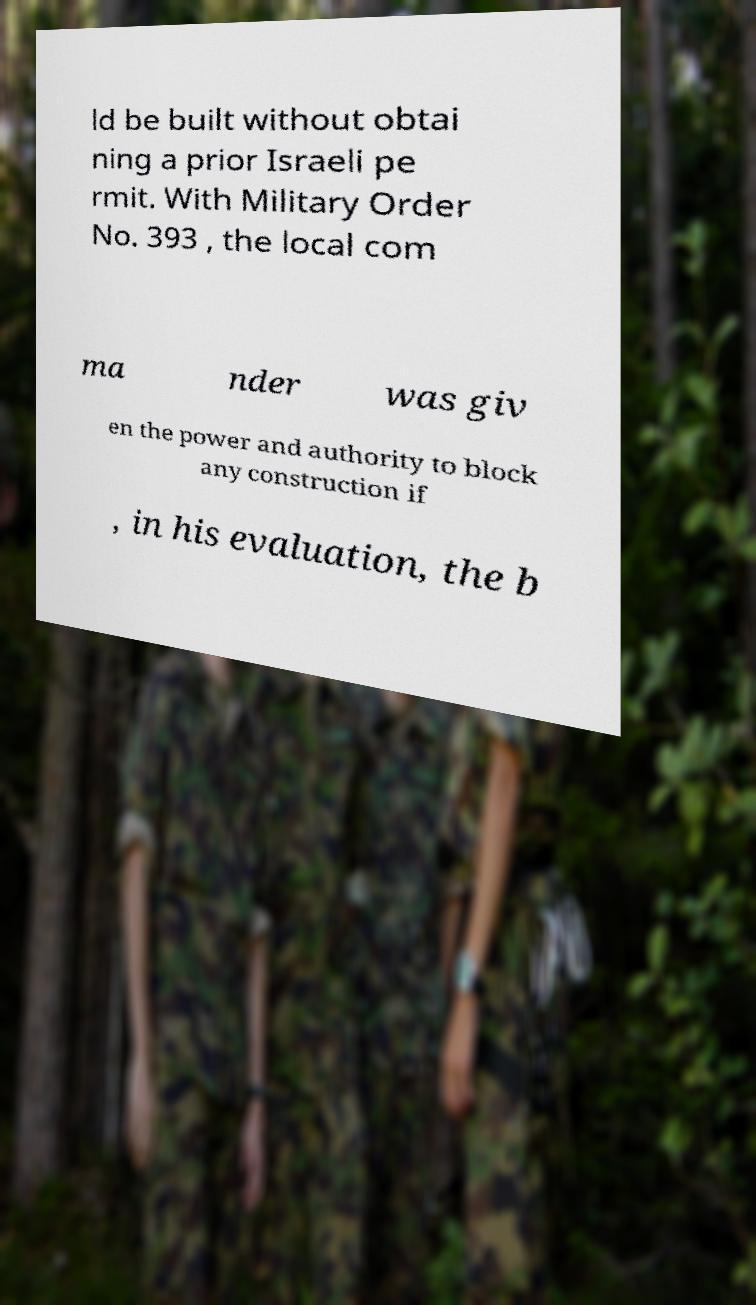Can you accurately transcribe the text from the provided image for me? ld be built without obtai ning a prior Israeli pe rmit. With Military Order No. 393 , the local com ma nder was giv en the power and authority to block any construction if , in his evaluation, the b 